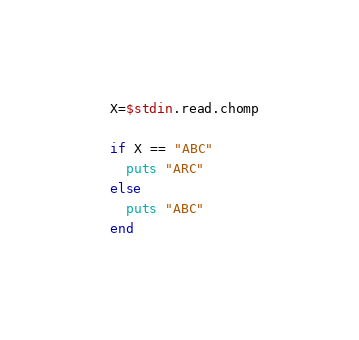Convert code to text. <code><loc_0><loc_0><loc_500><loc_500><_Ruby_>X=$stdin.read.chomp

if X == "ABC"
  puts "ARC"
else
  puts "ABC"
end
</code> 